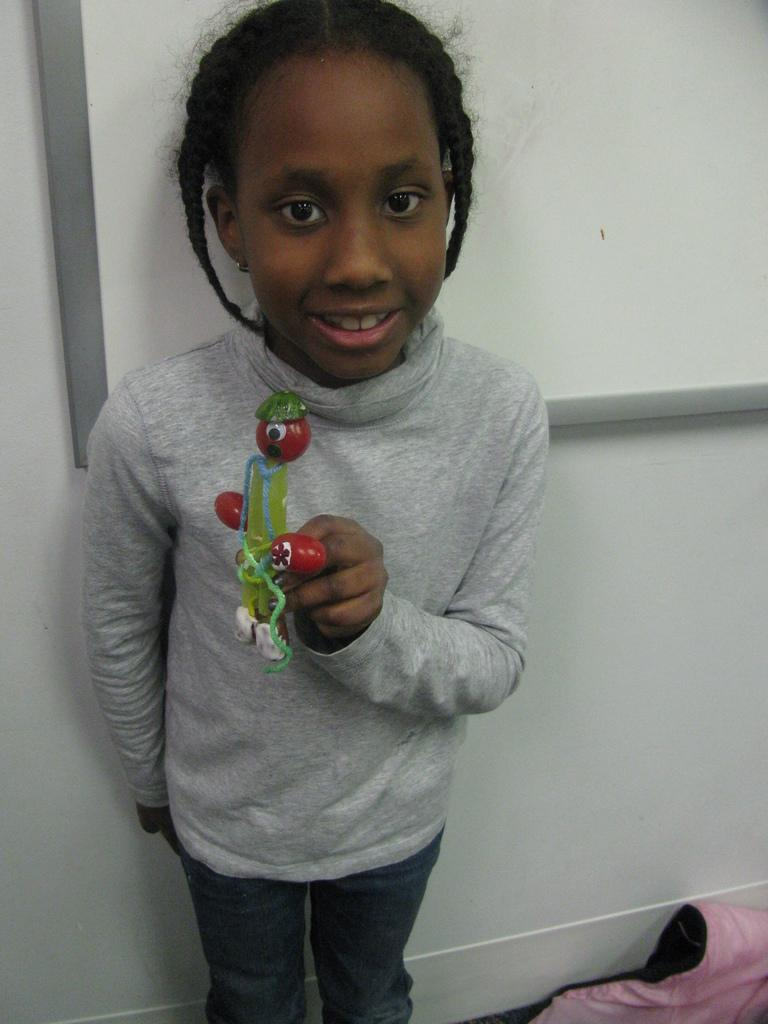What is the girl in the image holding? The girl is holding a toy in the image. What can be seen on the right side of the image? There is a cloth on the right side of the image. What is located at the top of the image? There is a board at the top of the image. What color is the wall in the center of the image? The wall in the center of the image is painted white. What type of truck can be seen driving on the wall in the image? There is no truck present in the image, and the wall is painted white. How does the goose interact with the girl holding the toy in the image? There is no goose present in the image; the girl is holding a toy. 